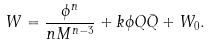Convert formula to latex. <formula><loc_0><loc_0><loc_500><loc_500>W = \frac { \phi ^ { n } } { n M ^ { n - 3 } } + k \phi Q \bar { Q } + W _ { 0 } .</formula> 